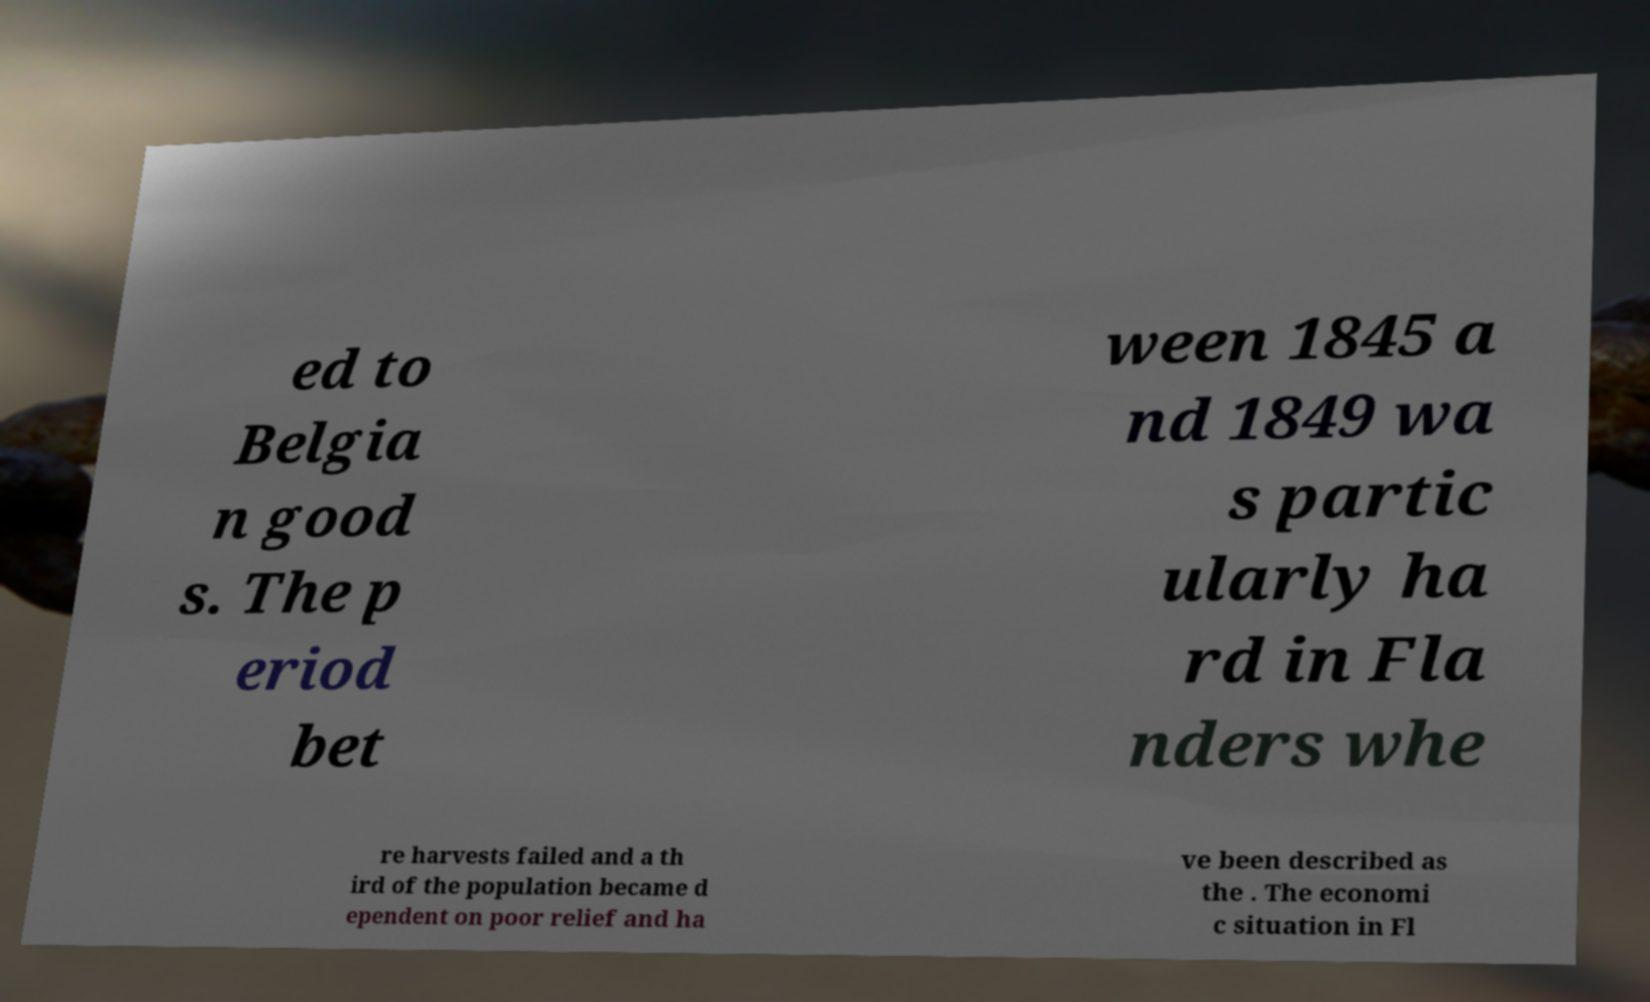Can you read and provide the text displayed in the image?This photo seems to have some interesting text. Can you extract and type it out for me? ed to Belgia n good s. The p eriod bet ween 1845 a nd 1849 wa s partic ularly ha rd in Fla nders whe re harvests failed and a th ird of the population became d ependent on poor relief and ha ve been described as the . The economi c situation in Fl 